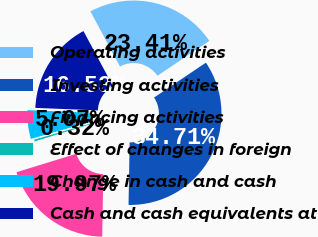Convert chart to OTSL. <chart><loc_0><loc_0><loc_500><loc_500><pie_chart><fcel>Operating activities<fcel>Investing activities<fcel>Financing activities<fcel>Effect of changes in foreign<fcel>Change in cash and cash<fcel>Cash and cash equivalents at<nl><fcel>23.41%<fcel>34.71%<fcel>19.97%<fcel>0.32%<fcel>5.07%<fcel>16.53%<nl></chart> 